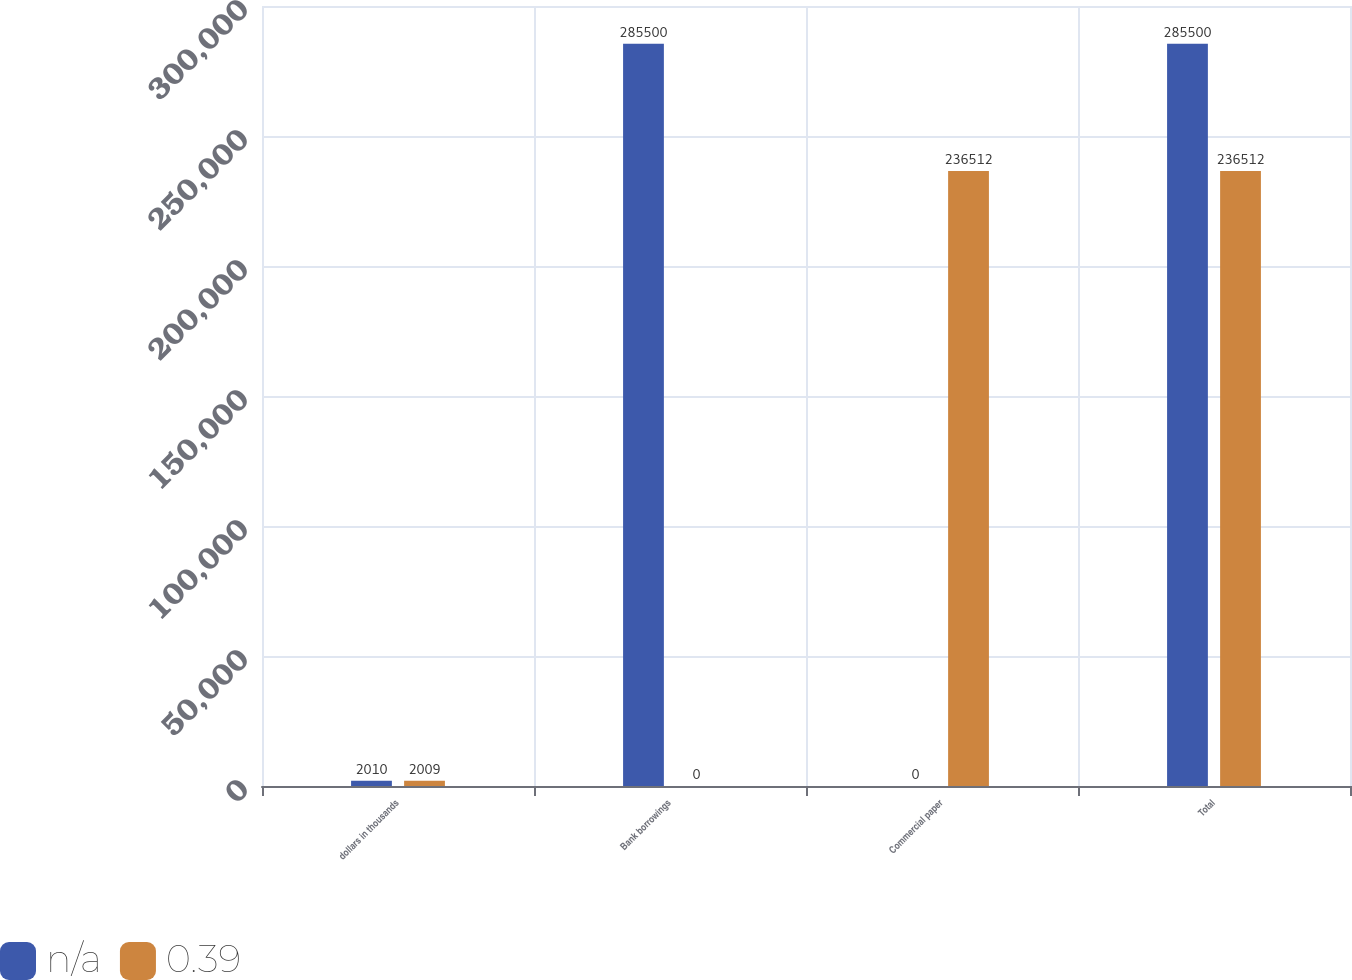<chart> <loc_0><loc_0><loc_500><loc_500><stacked_bar_chart><ecel><fcel>dollars in thousands<fcel>Bank borrowings<fcel>Commercial paper<fcel>Total<nl><fcel>nan<fcel>2010<fcel>285500<fcel>0<fcel>285500<nl><fcel>0.39<fcel>2009<fcel>0<fcel>236512<fcel>236512<nl></chart> 